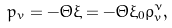Convert formula to latex. <formula><loc_0><loc_0><loc_500><loc_500>p _ { v } = - \Theta \xi = - \Theta \xi _ { 0 } \rho ^ { \nu } _ { v } ,</formula> 